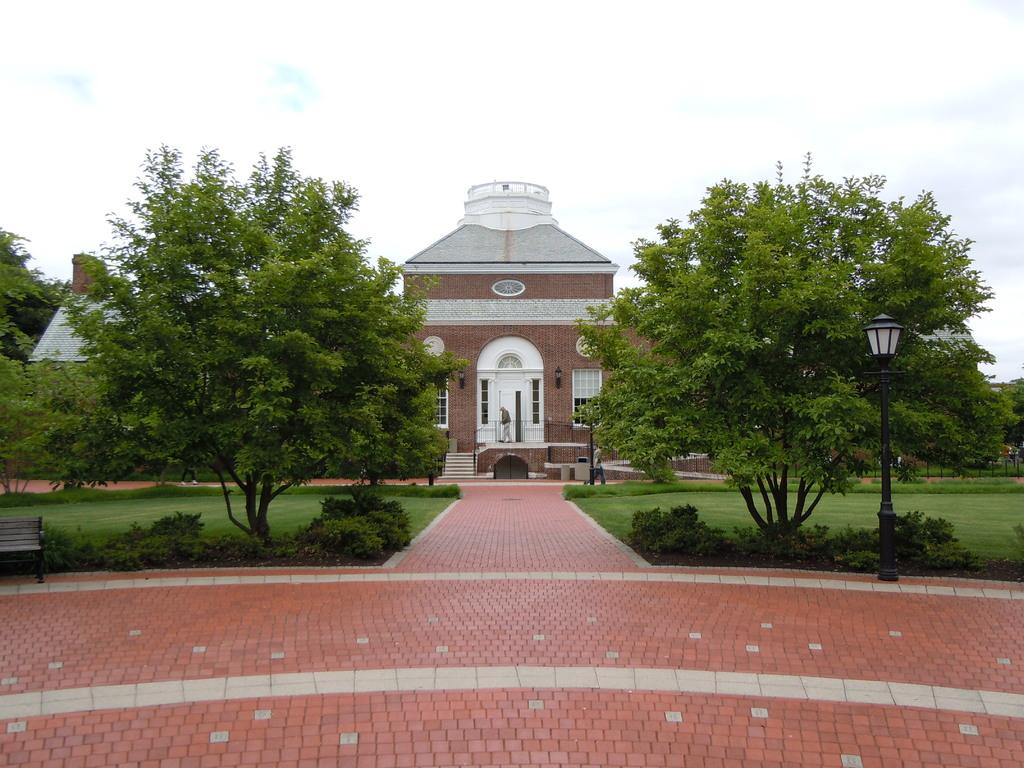What structure can be seen in the image? There is a light pole in the image. What type of vegetation is present in the image? There are trees with green color in the image. What can be seen in the background of the image? There is a building with brown and white colors in the background of the image. What color is the sky in the image? The sky is in white color in the image. How many degrees does the snake have in the image? There is no snake present in the image, so it is not possible to determine the number of degrees it might have. 